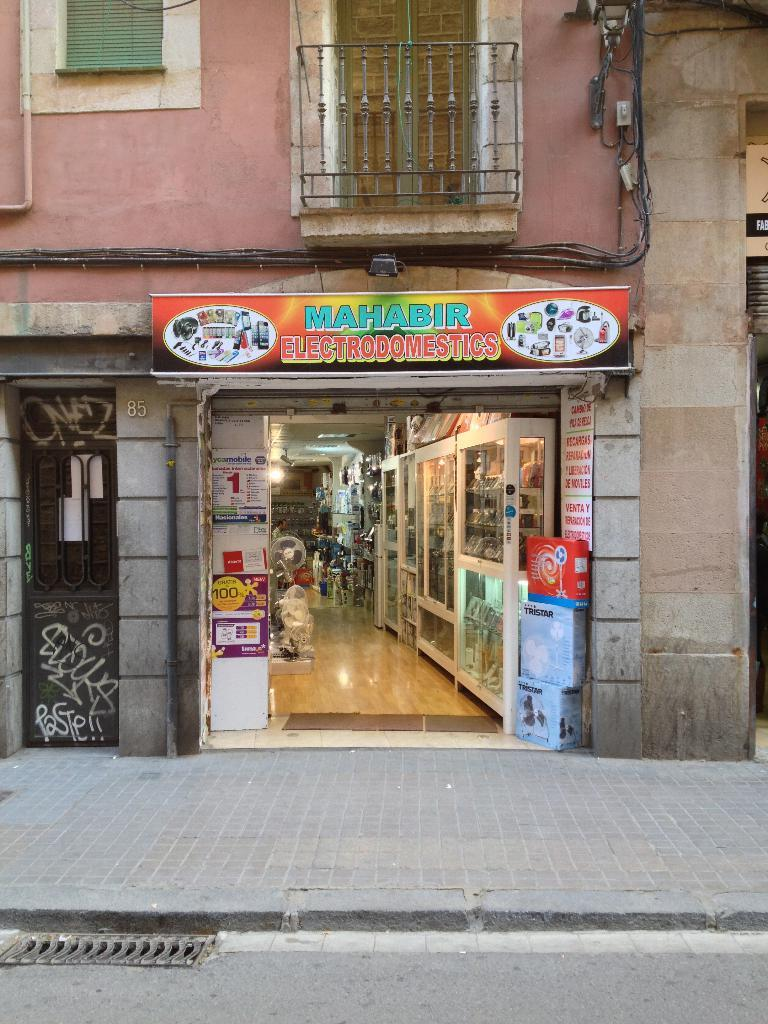Provide a one-sentence caption for the provided image. Mahabir electrodomestics building that is wide open on the side of the street. 